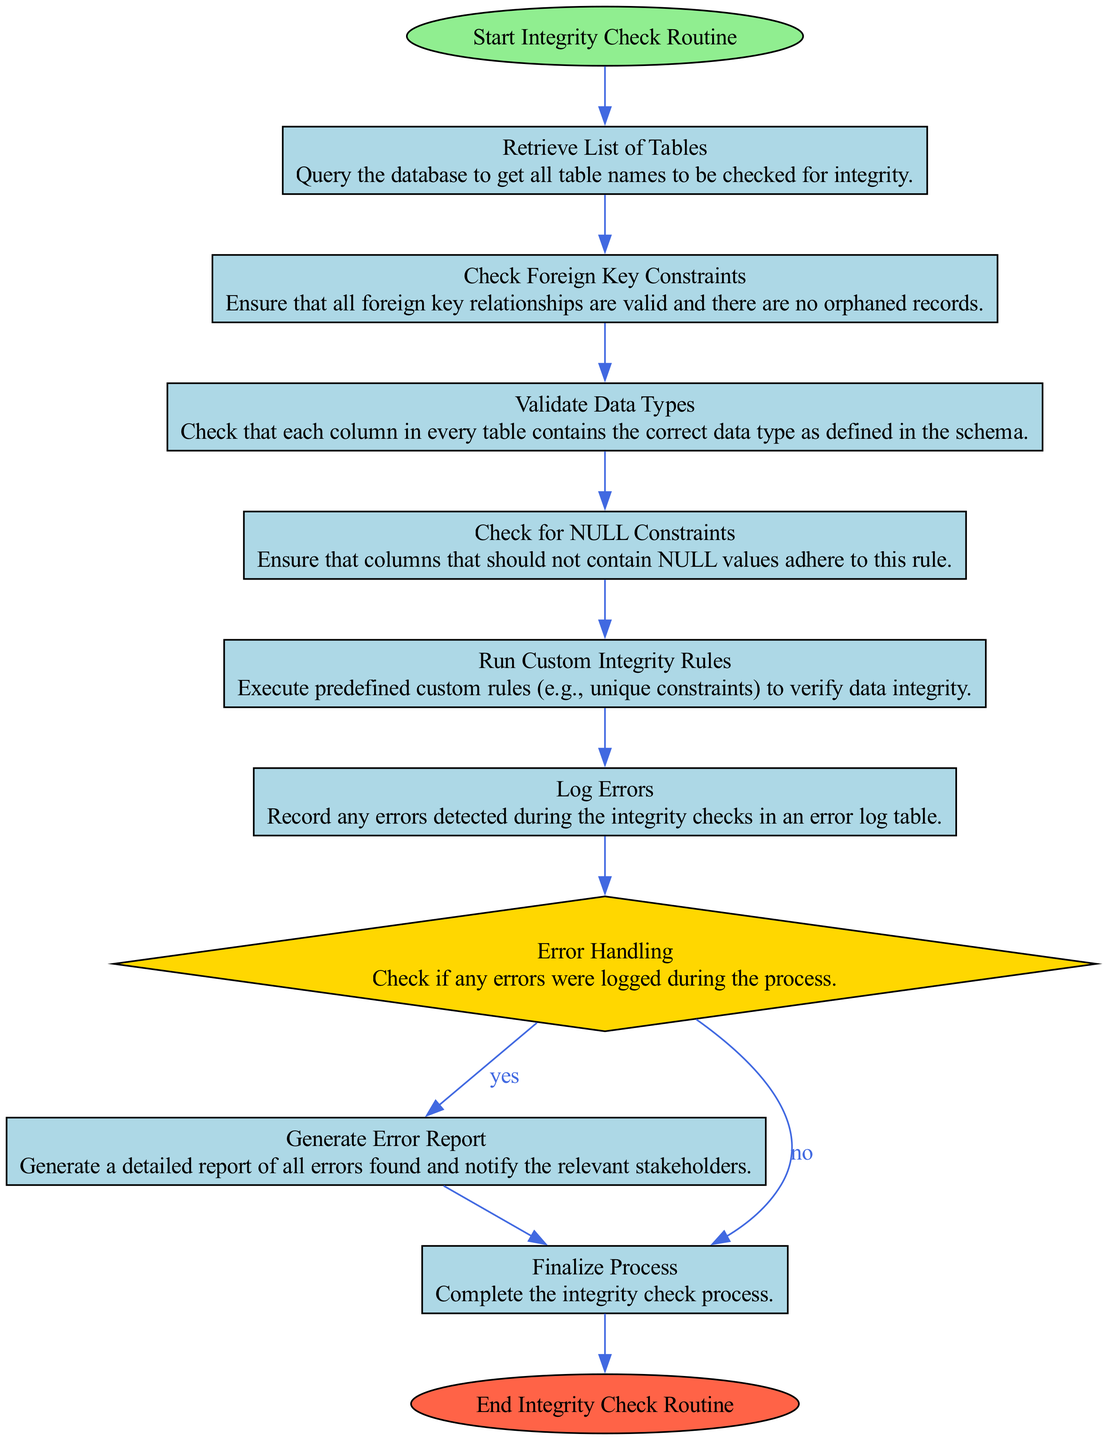What is the starting node of the flow chart? The flow chart begins with the node labeled "Start Integrity Check Routine," which indicates the initiation of the integrity checking process.
Answer: Start Integrity Check Routine How many process nodes are present in the diagram? The diagram includes five process nodes: "Retrieve List of Tables," "Check Foreign Key Constraints," "Validate Data Types," "Check for NULL Constraints," and "Run Custom Integrity Rules."
Answer: Five What happens if errors are logged during the integrity checks? If any errors are logged, the flow goes to the node labeled "Generate Error Report," where detailed reporting of errors occurs.
Answer: Generate Error Report Which decision determines the next step based on error logging? The decision node labeled "Error Handling" determines the next step based on whether any errors were logged, leading to either error reporting or finalizing the process.
Answer: Error Handling Which node is the final step in the integrity check routine? The final step in the routine is "End Integrity Check Routine," indicating the conclusion of the entire process.
Answer: End Integrity Check Routine What is the purpose of logging errors in the integrity check routine? The purpose of logging errors is to record any issues detected during the integrity checks, ensuring they can be reviewed and addressed later.
Answer: Record errors Which process validates data types in the database tables? The process that validates data types is labeled "Validate Data Types," where it checks that each column conforms to the defined data types in the schema.
Answer: Validate Data Types How are the nodes connected in the integrity check diagram? The nodes are connected sequentially based on the flow of operations for the integrity checks, where each node leads to the next step in the process.
Answer: Sequentially What is done after running custom integrity rules? After running custom integrity rules, the routine proceeds to log any errors that were detected during these checks.
Answer: Log Errors 